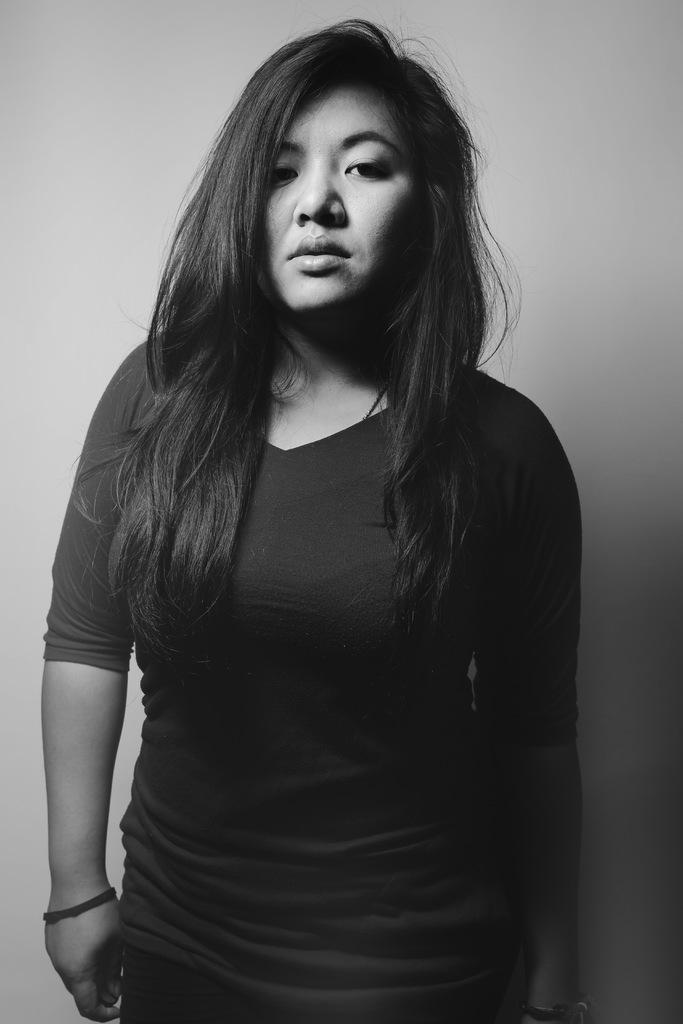What is the main subject in the foreground of the image? There is a person standing in the foreground of the image. Can you describe the background of the image? There is color visible in the background of the image. What type of straw is being used by the secretary in the image? There is no secretary or straw present in the image. 